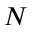Convert formula to latex. <formula><loc_0><loc_0><loc_500><loc_500>N</formula> 